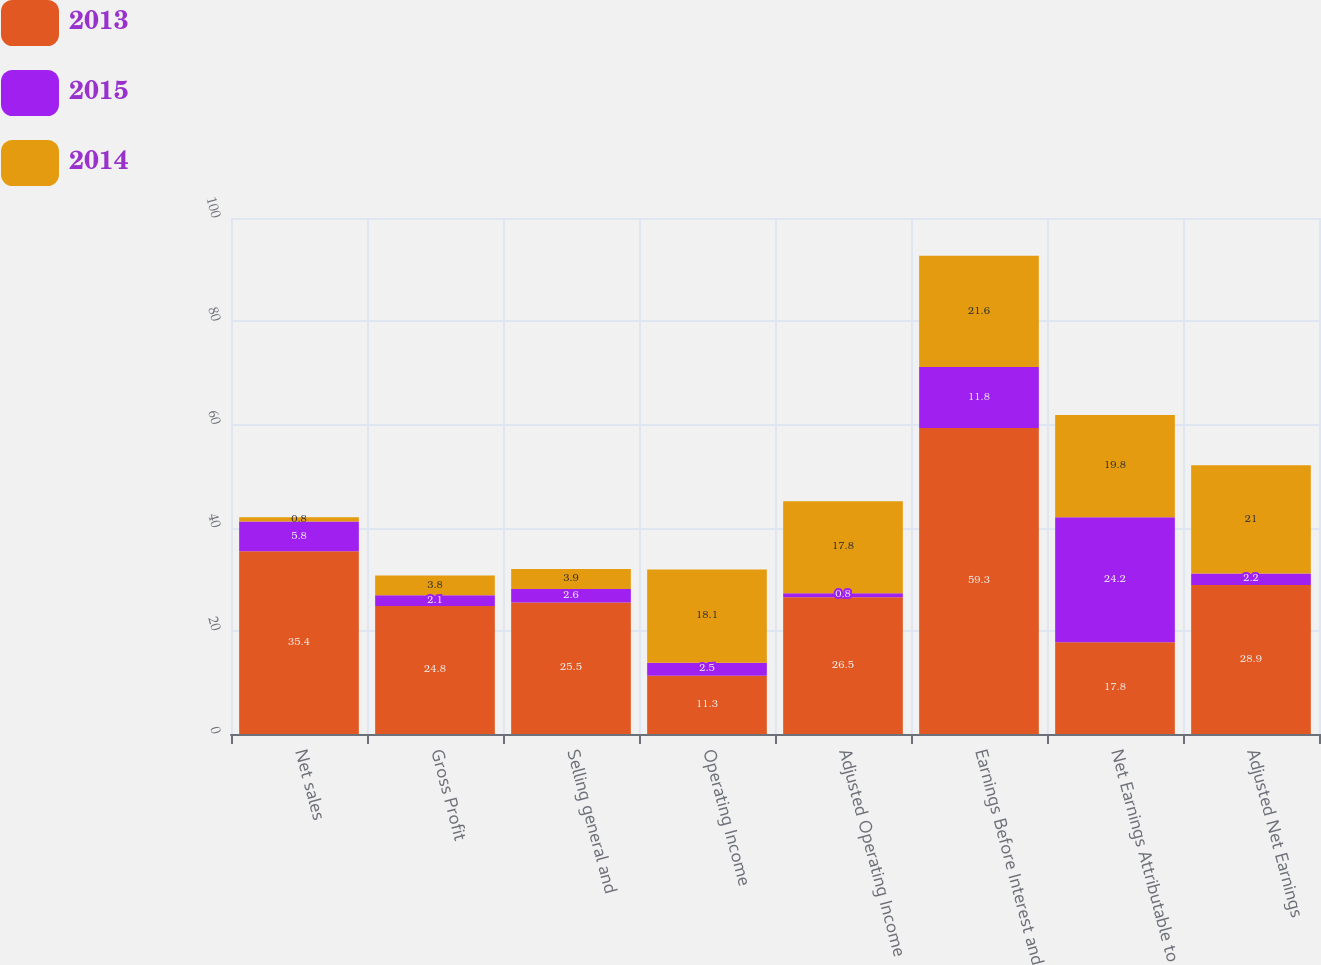Convert chart to OTSL. <chart><loc_0><loc_0><loc_500><loc_500><stacked_bar_chart><ecel><fcel>Net sales<fcel>Gross Profit<fcel>Selling general and<fcel>Operating Income<fcel>Adjusted Operating Income<fcel>Earnings Before Interest and<fcel>Net Earnings Attributable to<fcel>Adjusted Net Earnings<nl><fcel>2013<fcel>35.4<fcel>24.8<fcel>25.5<fcel>11.3<fcel>26.5<fcel>59.3<fcel>17.8<fcel>28.9<nl><fcel>2015<fcel>5.8<fcel>2.1<fcel>2.6<fcel>2.5<fcel>0.8<fcel>11.8<fcel>24.2<fcel>2.2<nl><fcel>2014<fcel>0.8<fcel>3.8<fcel>3.9<fcel>18.1<fcel>17.8<fcel>21.6<fcel>19.8<fcel>21<nl></chart> 